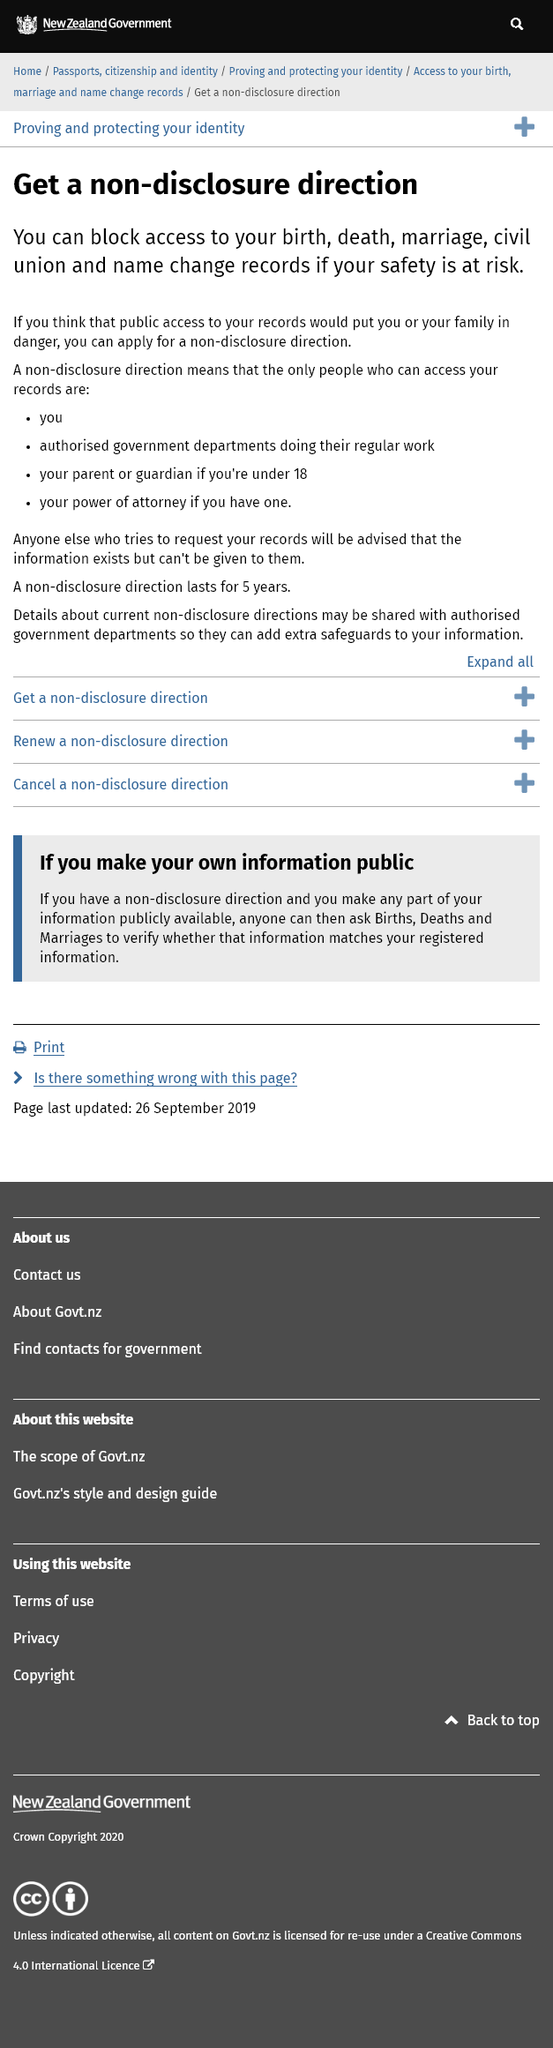Give some essential details in this illustration. Yes, it is possible for a minor's parents to access their marriage records if they are under the age of 18. You can access your own records even if you have a non-disclosure direction. You can prevent public access to name change records by taking certain actions. 